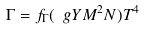Convert formula to latex. <formula><loc_0><loc_0><loc_500><loc_500>\Gamma = f _ { \Gamma } ( \ g Y M ^ { 2 } N ) T ^ { 4 }</formula> 